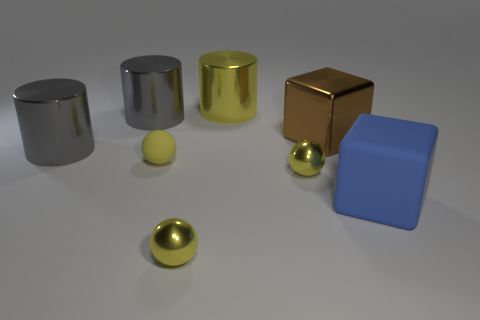Is the size of the yellow cylinder the same as the yellow matte sphere?
Ensure brevity in your answer.  No. There is a yellow object that is the same material as the blue cube; what size is it?
Make the answer very short. Small. Do the big blue thing and the large brown thing have the same shape?
Offer a terse response. Yes. There is a cube that is the same size as the blue thing; what is its color?
Give a very brief answer. Brown. There is a large gray thing that is in front of the brown cube; what is its shape?
Offer a terse response. Cylinder. There is a brown thing; is its shape the same as the small yellow metal object that is to the left of the big yellow cylinder?
Your answer should be compact. No. Is the number of large gray metallic things that are on the left side of the blue thing the same as the number of yellow rubber objects that are to the right of the big brown block?
Keep it short and to the point. No. Do the large thing that is in front of the tiny yellow matte thing and the tiny metal ball that is on the right side of the big yellow shiny cylinder have the same color?
Your answer should be compact. No. Is the number of yellow shiny objects to the left of the yellow rubber thing greater than the number of big blue things?
Offer a very short reply. No. What is the material of the large blue thing?
Offer a very short reply. Rubber. 